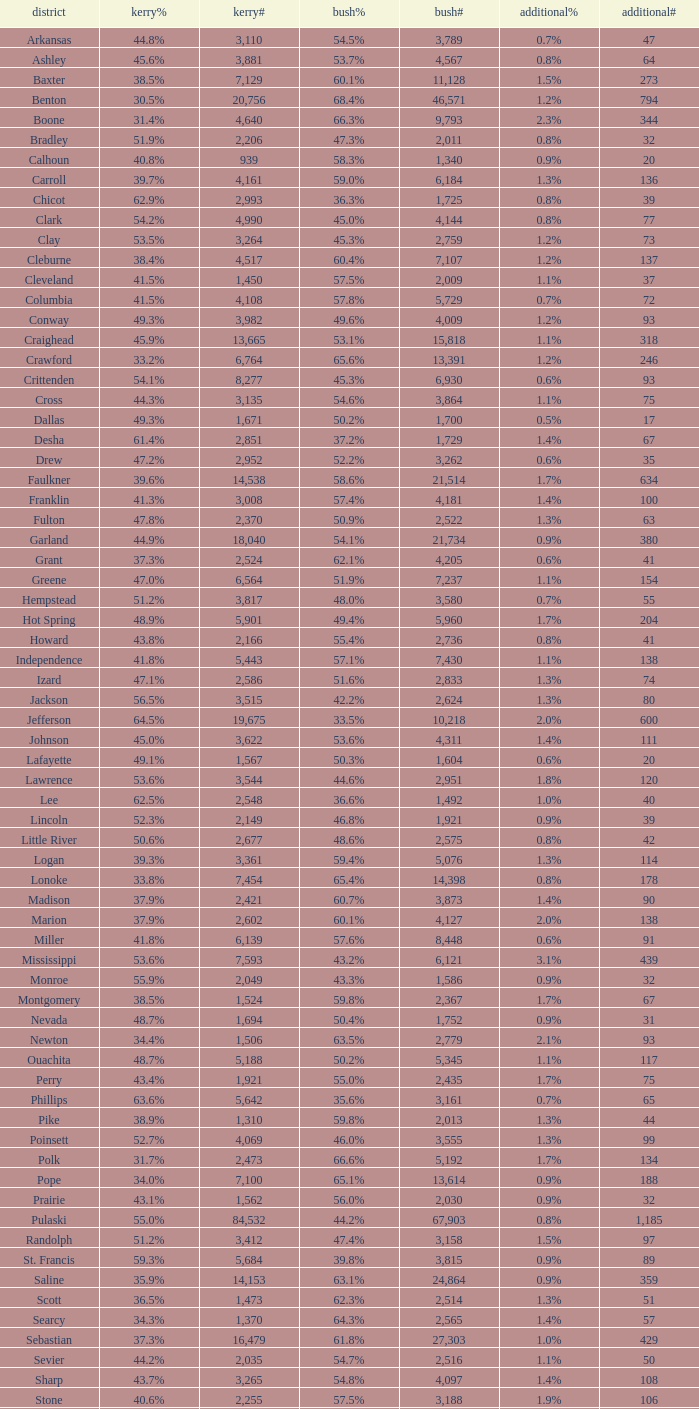What is the lowest Kerry#, when Others# is "106", and when Bush# is less than 3,188? None. 